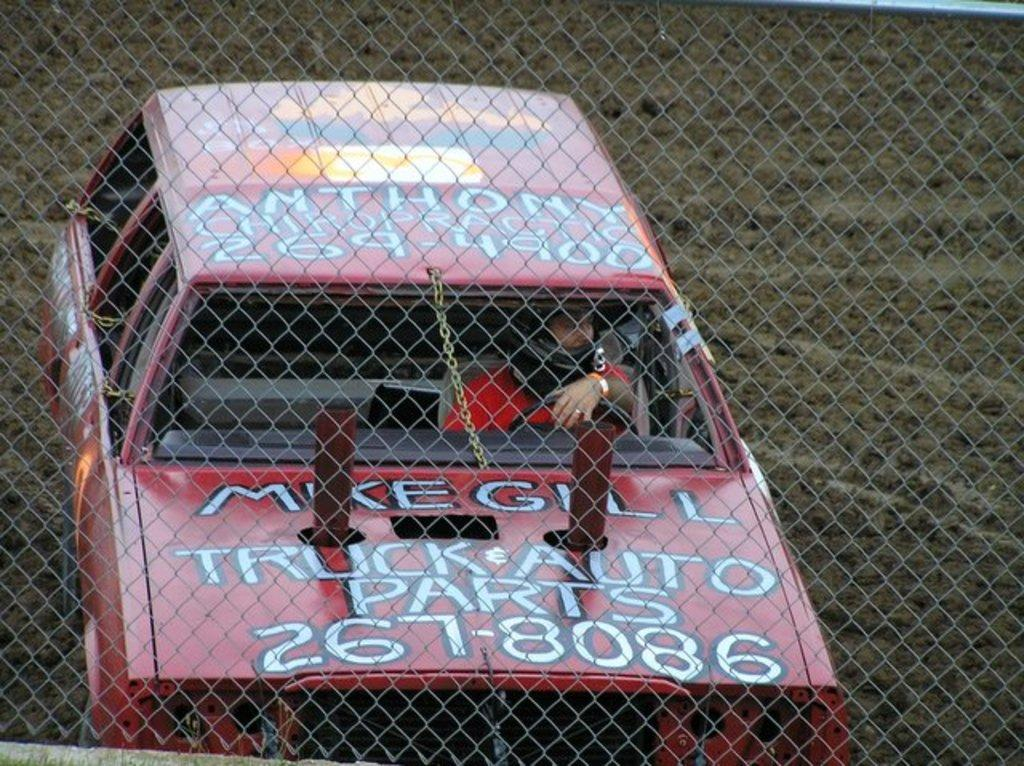What is the main subject of the image? The main subject of the image is a person driving a car. What can be seen in the foreground of the image? There is a grill in the foreground of the image. What scent is emanating from the card in the image? There is no card present in the image, so it is not possible to determine any scent associated with it. 